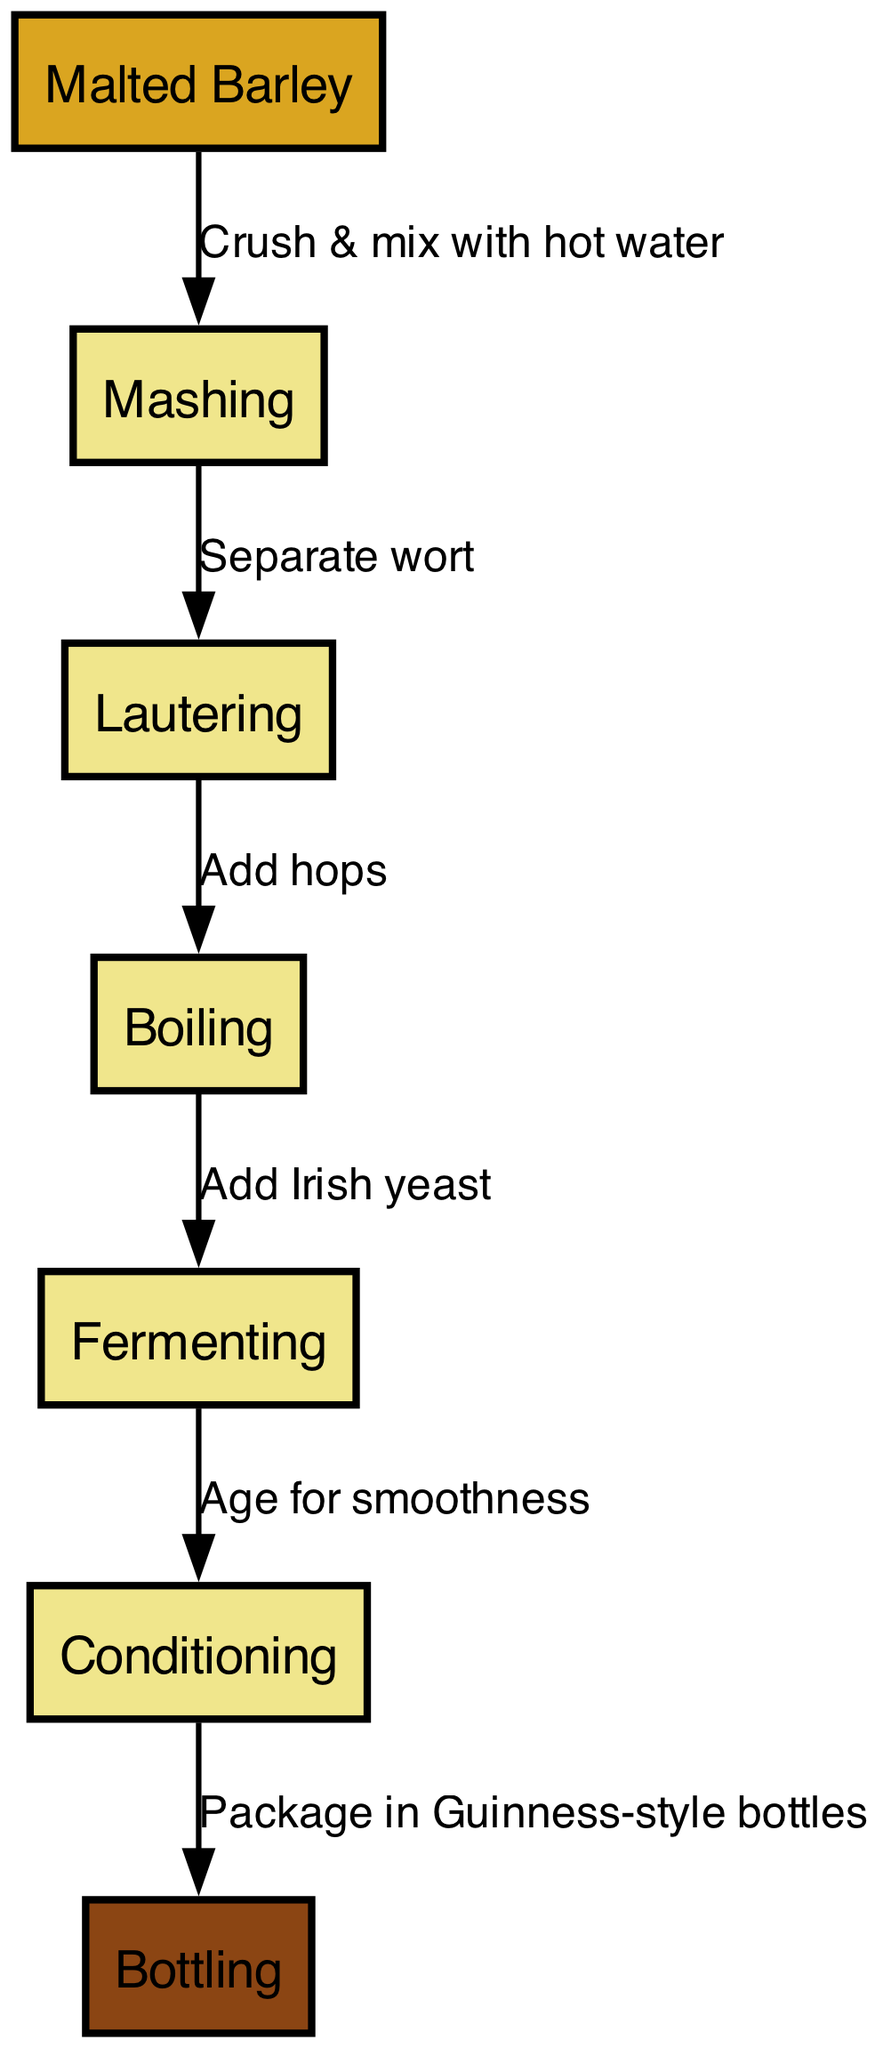What is the first step in the beer brewing process? The first node in the diagram is Malted Barley, which indicates that the brewing process starts with this ingredient.
Answer: Malted Barley How many nodes are there in the diagram? The diagram mentions a total of 7 nodes, representing different stages in the brewing process.
Answer: 7 What is added after mashing? From the edge connecting the nodes, after mashing (Node 2), the next step is Lautering (Node 3), which is where the wort is separated.
Answer: Lautering What ingredient is added during boiling? The edge from the Boiling node (Node 4) shows that hops are added during this stage, as indicated by the label on the edge connecting the nodes.
Answer: Hops What is the final step of the brewing process? The last node in the diagram is Bottling (Node 7), which indicates that the final step is to package the beer into bottles.
Answer: Bottling How does fermenting relate to conditioning? From the diagram, after the Fermenting step (Node 5), the next step is Conditioning (Node 6), showing a direct transition in the brewing process.
Answer: Fermenting What is the purpose of conditioning in the brewing process? According to the edge label that connects Fermenting to Conditioning, the purpose is to age the beer for smoothness, ensuring a better flavor profile.
Answer: Age for smoothness Which step involves adding Irish yeast? The diagram shows that Irish yeast is added at the Boiling stage (Node 4) before the beer is transferred to Fermenting (Node 5).
Answer: Boiling What color is the Malted Barley node? The diagram customizes the nodes, with the Malted Barley node (Node 1) being filled with a golden color, as specified in the node style attributes.
Answer: Golden 